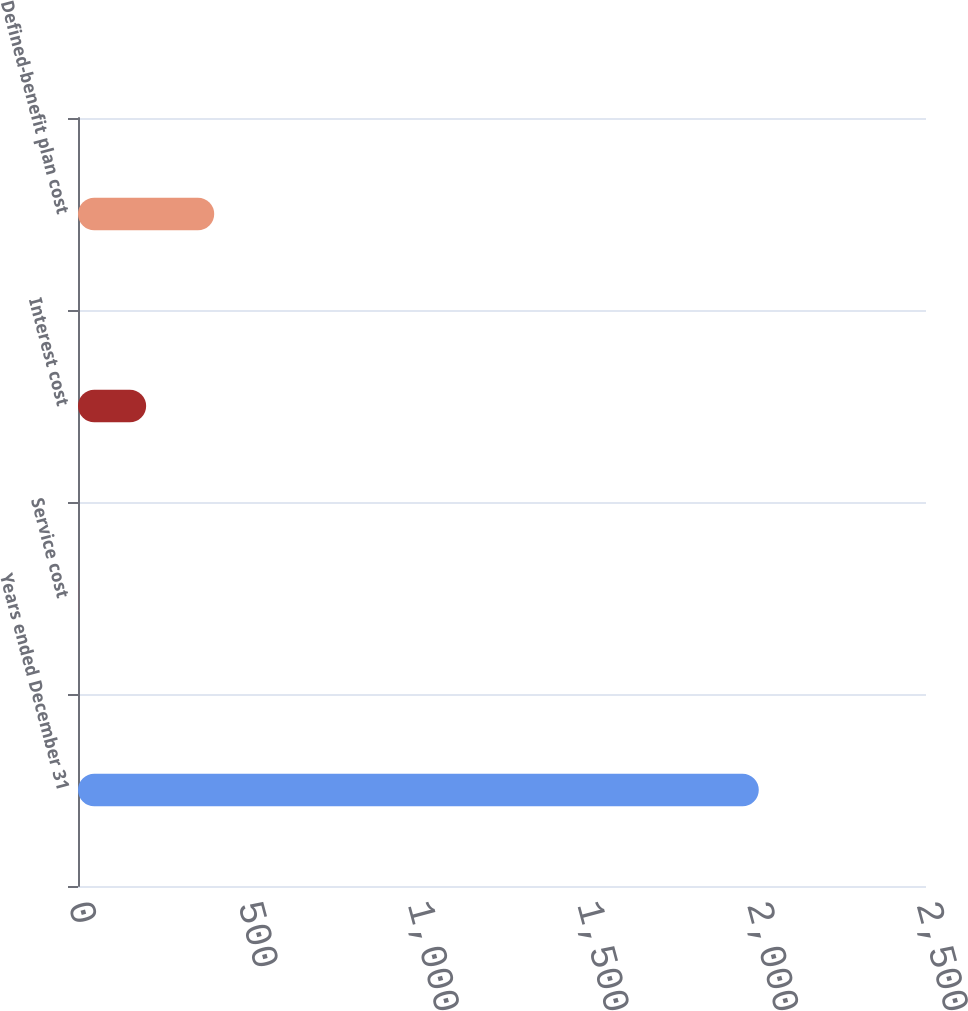Convert chart. <chart><loc_0><loc_0><loc_500><loc_500><bar_chart><fcel>Years ended December 31<fcel>Service cost<fcel>Interest cost<fcel>Defined-benefit plan cost<nl><fcel>2007<fcel>0.2<fcel>200.88<fcel>401.56<nl></chart> 